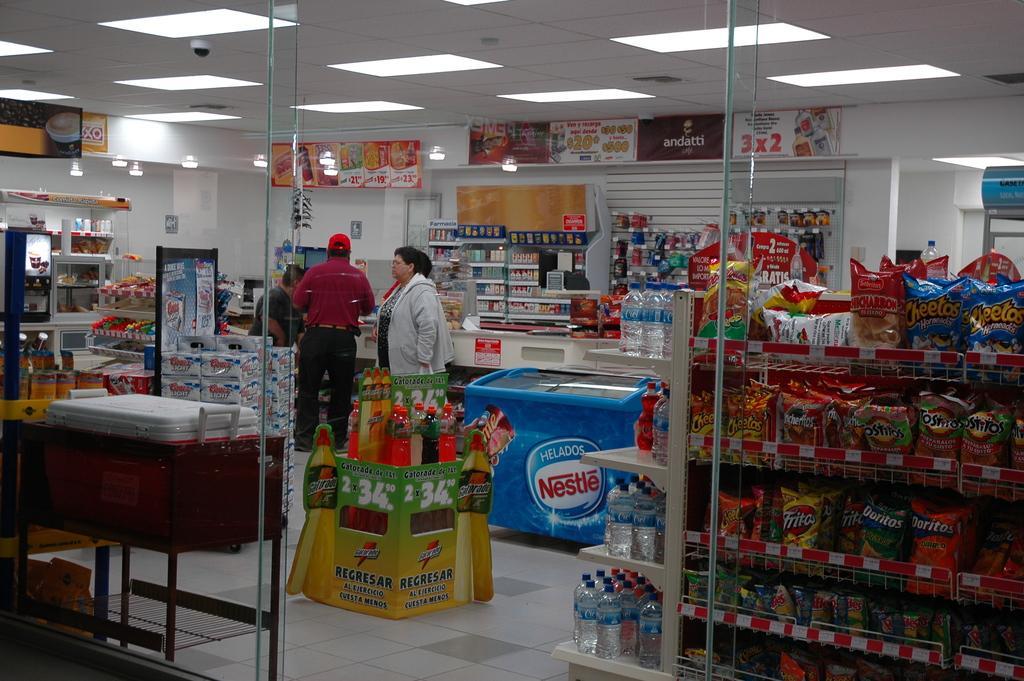Could you give a brief overview of what you see in this image? This image is taken in the store. In this image there are racks and we can see goods placed in the racks and there are bottles and there are lights. We can see glass doors and there is a refrigerator. We can see people. In the background there is a wall. 